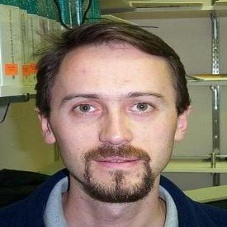What can be inferred about the person's emotions from his expression in the image? The man in the image appears to have a neutral and calm expression. His direct gaze into the camera and the slight downturn of his lips suggest a serene or contemplative state. This might indicate that he is in a moment of reflection or simply posing controlled for the camera. 